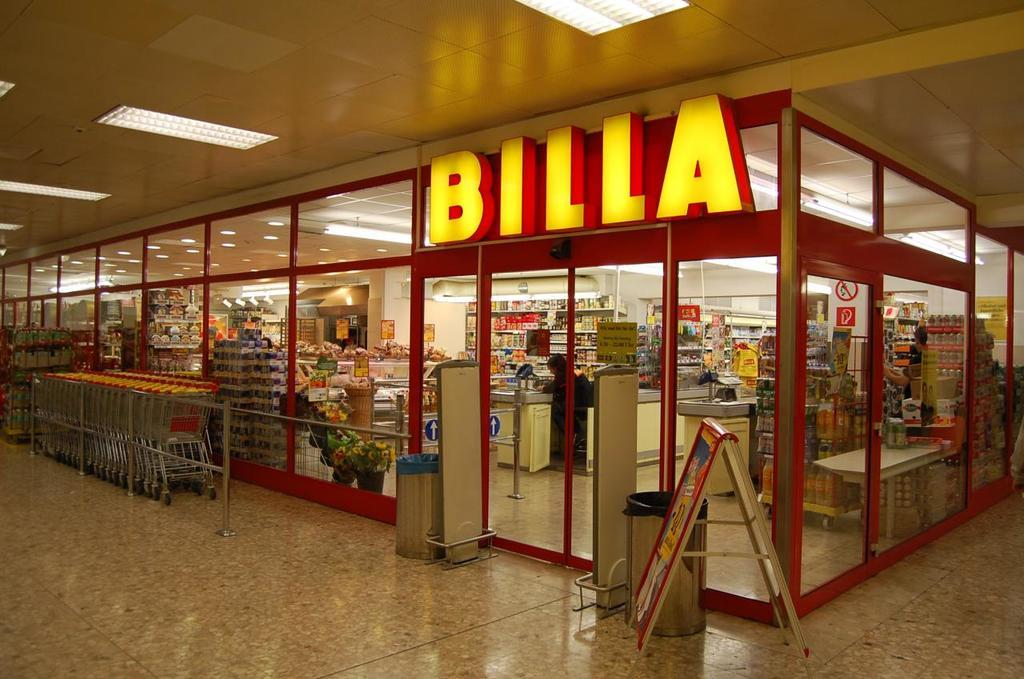<image>
Summarize the visual content of the image. A shop in a mall which is named Billa. 